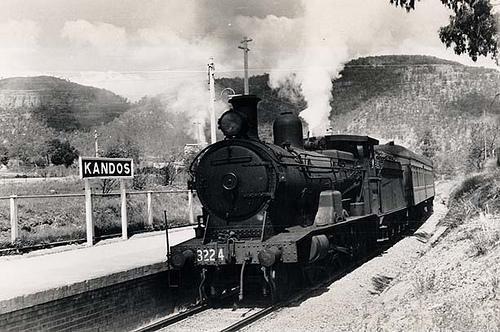How many people are sitting in the cart?
Give a very brief answer. 0. 